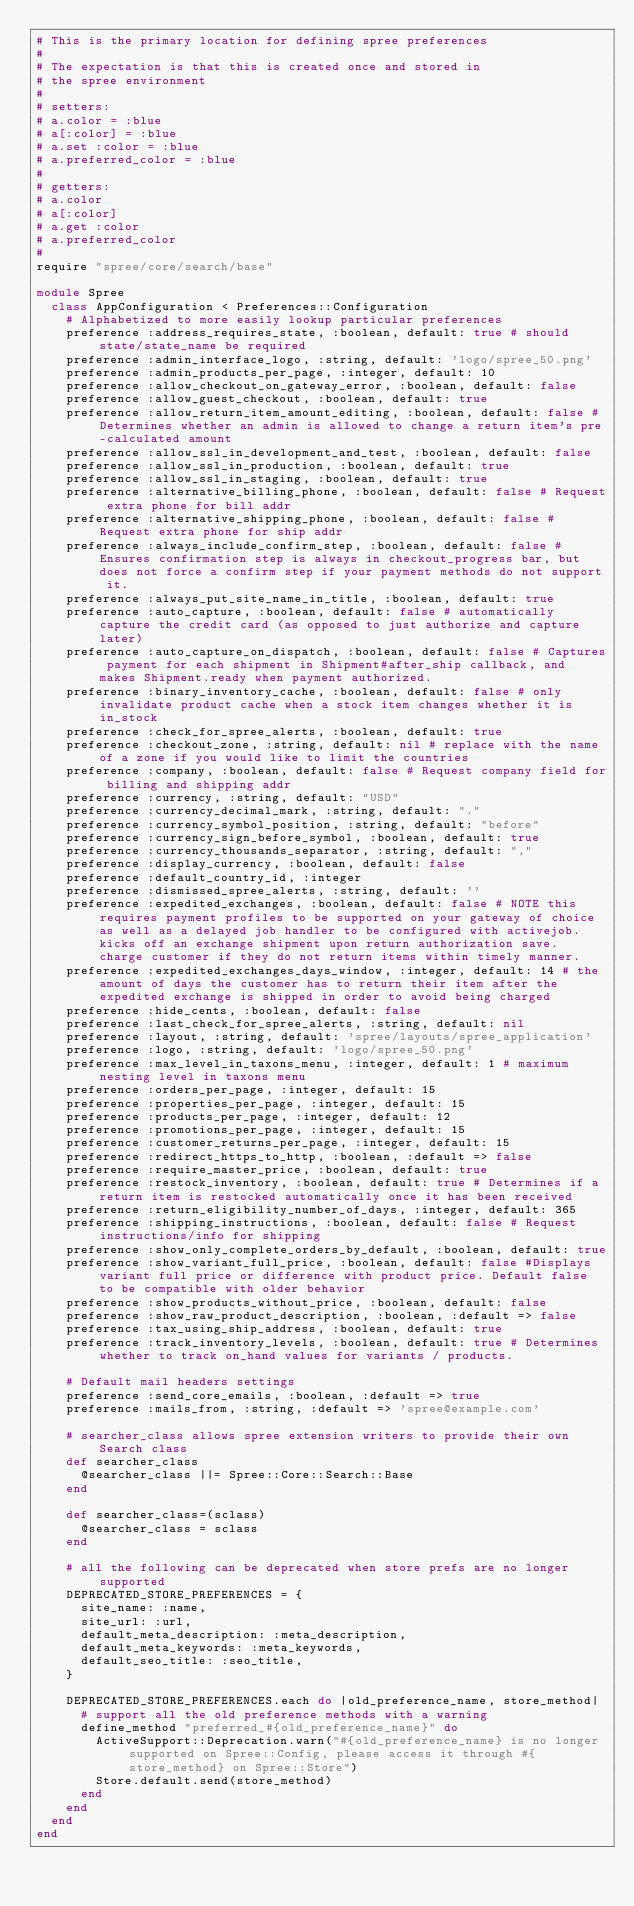Convert code to text. <code><loc_0><loc_0><loc_500><loc_500><_Ruby_># This is the primary location for defining spree preferences
#
# The expectation is that this is created once and stored in
# the spree environment
#
# setters:
# a.color = :blue
# a[:color] = :blue
# a.set :color = :blue
# a.preferred_color = :blue
#
# getters:
# a.color
# a[:color]
# a.get :color
# a.preferred_color
#
require "spree/core/search/base"

module Spree
  class AppConfiguration < Preferences::Configuration
    # Alphabetized to more easily lookup particular preferences
    preference :address_requires_state, :boolean, default: true # should state/state_name be required
    preference :admin_interface_logo, :string, default: 'logo/spree_50.png'
    preference :admin_products_per_page, :integer, default: 10
    preference :allow_checkout_on_gateway_error, :boolean, default: false
    preference :allow_guest_checkout, :boolean, default: true
    preference :allow_return_item_amount_editing, :boolean, default: false # Determines whether an admin is allowed to change a return item's pre-calculated amount
    preference :allow_ssl_in_development_and_test, :boolean, default: false
    preference :allow_ssl_in_production, :boolean, default: true
    preference :allow_ssl_in_staging, :boolean, default: true
    preference :alternative_billing_phone, :boolean, default: false # Request extra phone for bill addr
    preference :alternative_shipping_phone, :boolean, default: false # Request extra phone for ship addr
    preference :always_include_confirm_step, :boolean, default: false # Ensures confirmation step is always in checkout_progress bar, but does not force a confirm step if your payment methods do not support it.
    preference :always_put_site_name_in_title, :boolean, default: true
    preference :auto_capture, :boolean, default: false # automatically capture the credit card (as opposed to just authorize and capture later)
    preference :auto_capture_on_dispatch, :boolean, default: false # Captures payment for each shipment in Shipment#after_ship callback, and makes Shipment.ready when payment authorized.
    preference :binary_inventory_cache, :boolean, default: false # only invalidate product cache when a stock item changes whether it is in_stock
    preference :check_for_spree_alerts, :boolean, default: true
    preference :checkout_zone, :string, default: nil # replace with the name of a zone if you would like to limit the countries
    preference :company, :boolean, default: false # Request company field for billing and shipping addr
    preference :currency, :string, default: "USD"
    preference :currency_decimal_mark, :string, default: "."
    preference :currency_symbol_position, :string, default: "before"
    preference :currency_sign_before_symbol, :boolean, default: true
    preference :currency_thousands_separator, :string, default: ","
    preference :display_currency, :boolean, default: false
    preference :default_country_id, :integer
    preference :dismissed_spree_alerts, :string, default: ''
    preference :expedited_exchanges, :boolean, default: false # NOTE this requires payment profiles to be supported on your gateway of choice as well as a delayed job handler to be configured with activejob. kicks off an exchange shipment upon return authorization save. charge customer if they do not return items within timely manner.
    preference :expedited_exchanges_days_window, :integer, default: 14 # the amount of days the customer has to return their item after the expedited exchange is shipped in order to avoid being charged
    preference :hide_cents, :boolean, default: false
    preference :last_check_for_spree_alerts, :string, default: nil
    preference :layout, :string, default: 'spree/layouts/spree_application'
    preference :logo, :string, default: 'logo/spree_50.png'
    preference :max_level_in_taxons_menu, :integer, default: 1 # maximum nesting level in taxons menu
    preference :orders_per_page, :integer, default: 15
    preference :properties_per_page, :integer, default: 15
    preference :products_per_page, :integer, default: 12
    preference :promotions_per_page, :integer, default: 15
    preference :customer_returns_per_page, :integer, default: 15
    preference :redirect_https_to_http, :boolean, :default => false
    preference :require_master_price, :boolean, default: true
    preference :restock_inventory, :boolean, default: true # Determines if a return item is restocked automatically once it has been received
    preference :return_eligibility_number_of_days, :integer, default: 365
    preference :shipping_instructions, :boolean, default: false # Request instructions/info for shipping
    preference :show_only_complete_orders_by_default, :boolean, default: true
    preference :show_variant_full_price, :boolean, default: false #Displays variant full price or difference with product price. Default false to be compatible with older behavior
    preference :show_products_without_price, :boolean, default: false
    preference :show_raw_product_description, :boolean, :default => false
    preference :tax_using_ship_address, :boolean, default: true
    preference :track_inventory_levels, :boolean, default: true # Determines whether to track on_hand values for variants / products.

    # Default mail headers settings
    preference :send_core_emails, :boolean, :default => true
    preference :mails_from, :string, :default => 'spree@example.com'

    # searcher_class allows spree extension writers to provide their own Search class
    def searcher_class
      @searcher_class ||= Spree::Core::Search::Base
    end

    def searcher_class=(sclass)
      @searcher_class = sclass
    end

    # all the following can be deprecated when store prefs are no longer supported
    DEPRECATED_STORE_PREFERENCES = {
      site_name: :name,
      site_url: :url,
      default_meta_description: :meta_description,
      default_meta_keywords: :meta_keywords,
      default_seo_title: :seo_title,
    }

    DEPRECATED_STORE_PREFERENCES.each do |old_preference_name, store_method|
      # support all the old preference methods with a warning
      define_method "preferred_#{old_preference_name}" do
        ActiveSupport::Deprecation.warn("#{old_preference_name} is no longer supported on Spree::Config, please access it through #{store_method} on Spree::Store")
        Store.default.send(store_method)
      end
    end
  end
end
</code> 